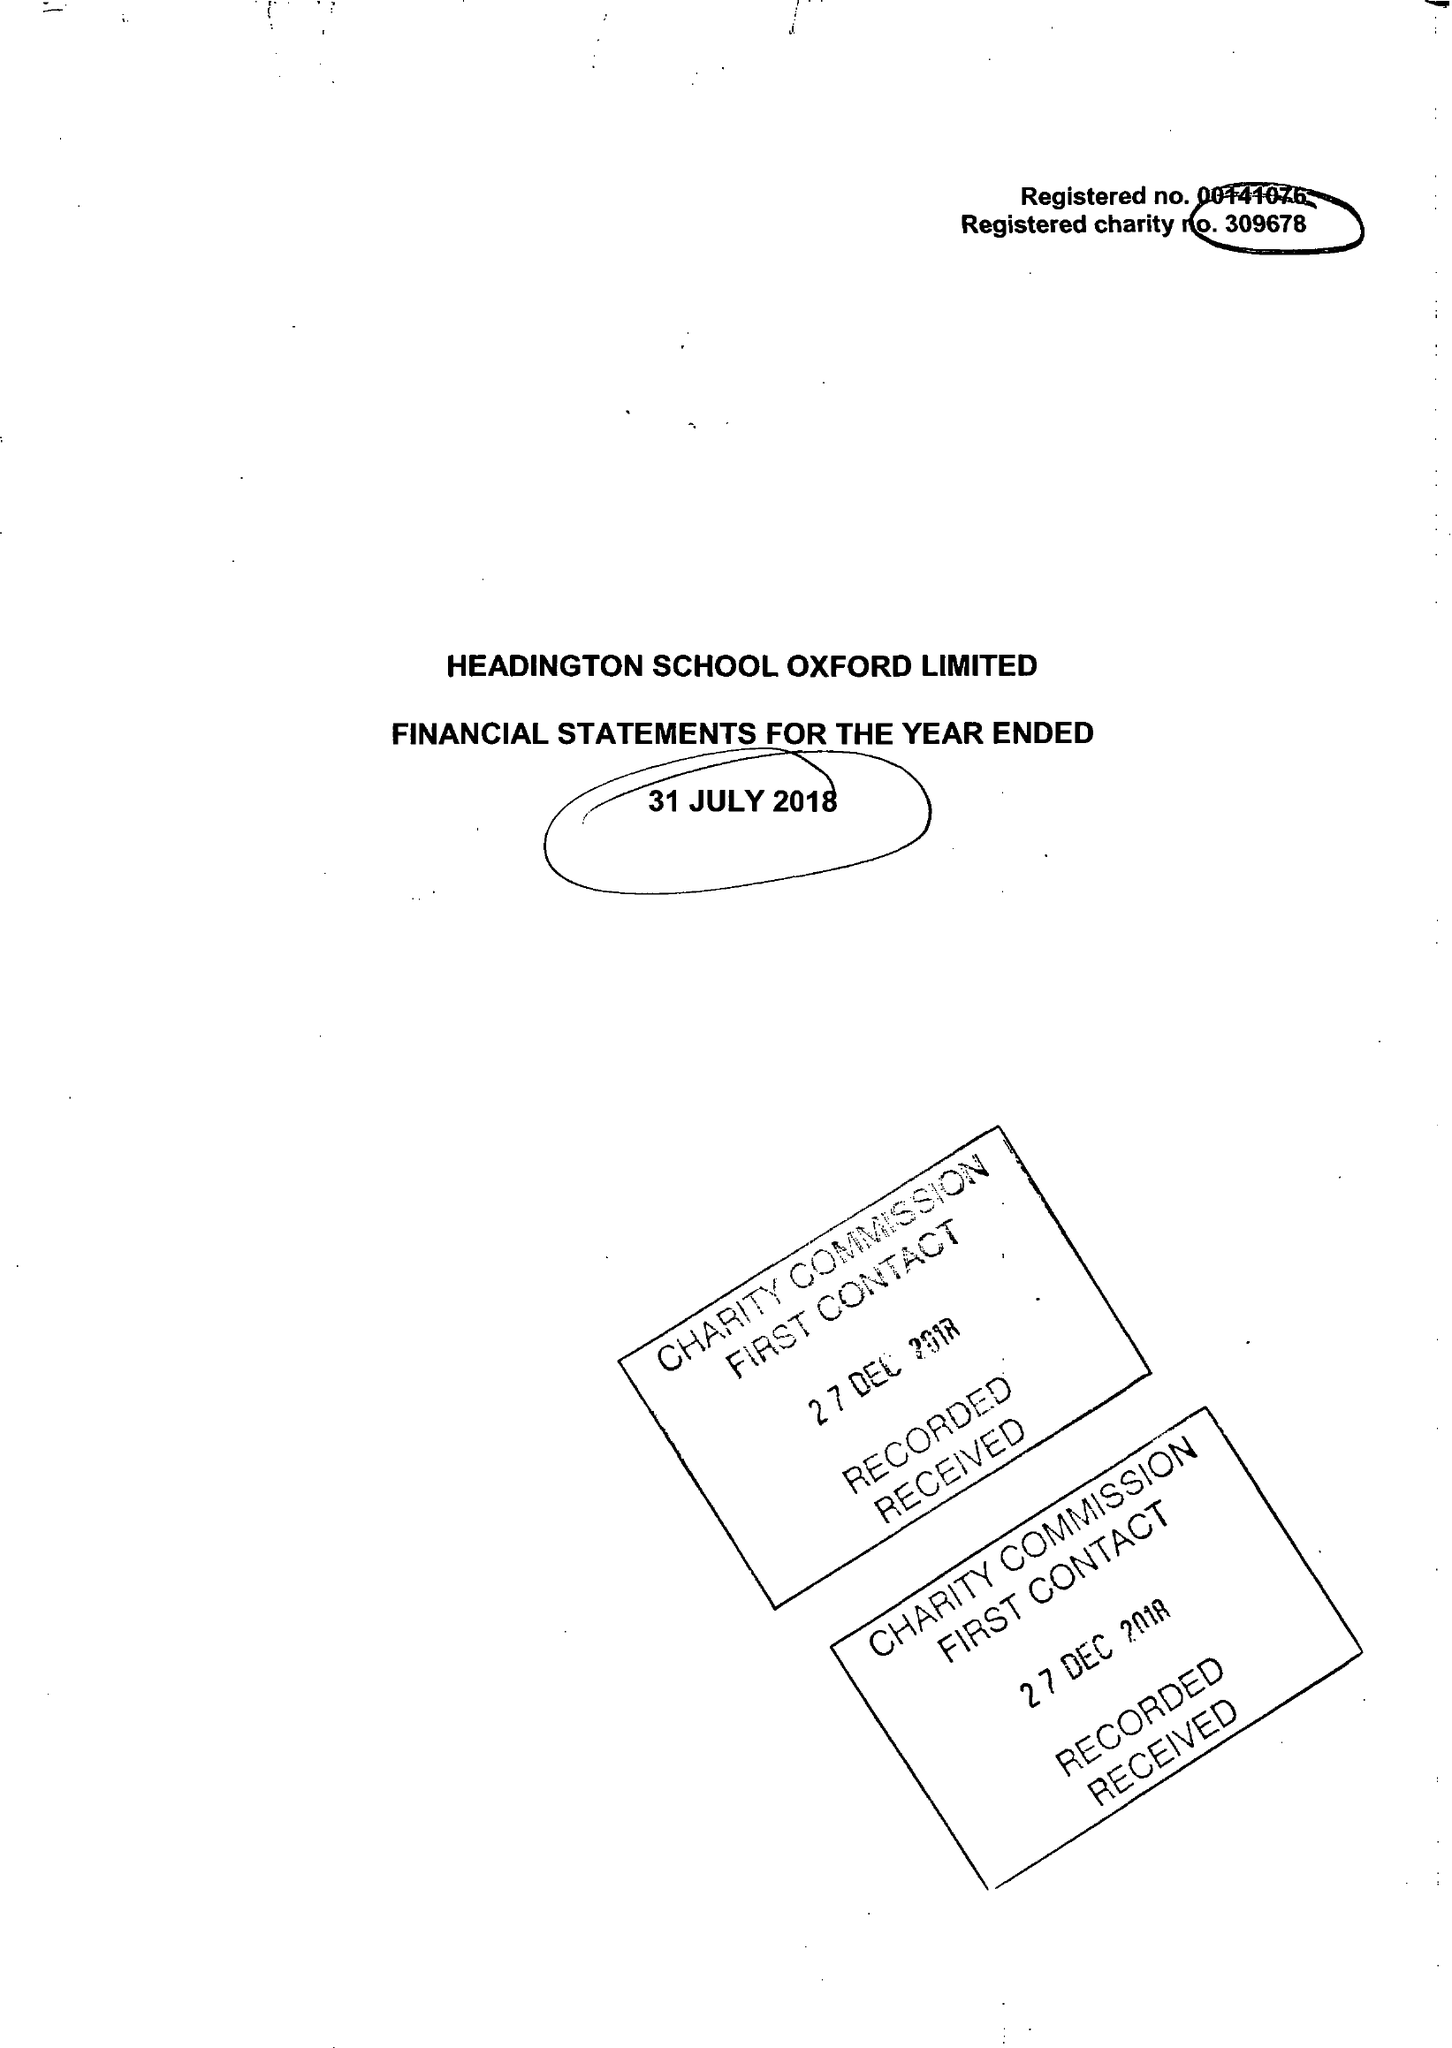What is the value for the address__post_town?
Answer the question using a single word or phrase. OXFORD 